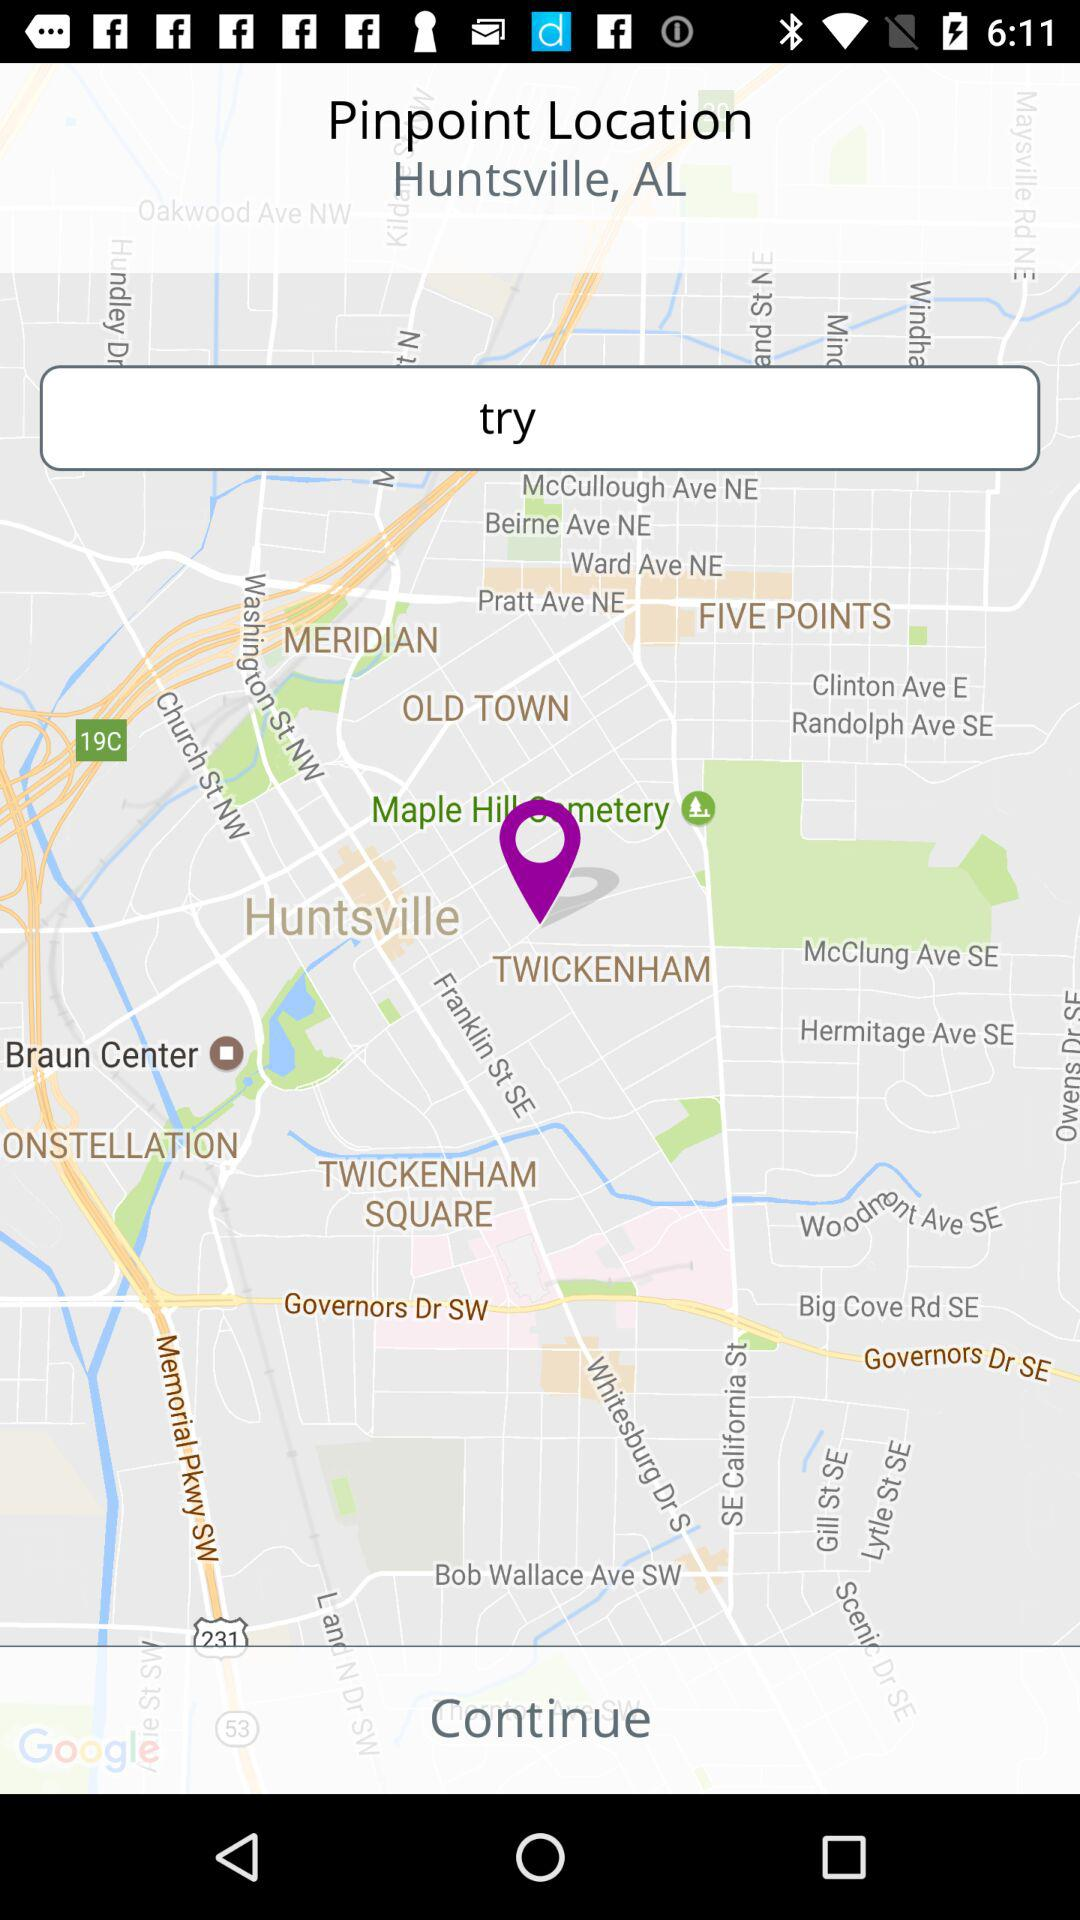What is the current location? The current location is Huntsville, AL. 